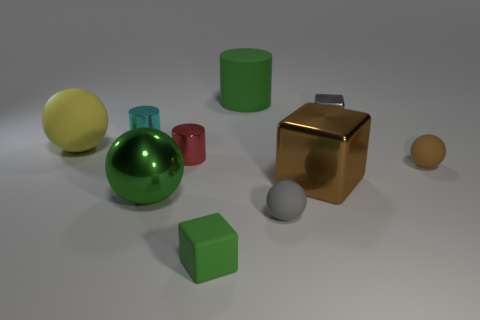Subtract all tiny cubes. How many cubes are left? 1 Subtract 3 spheres. How many spheres are left? 1 Subtract all green cylinders. How many cylinders are left? 2 Subtract all blue cylinders. Subtract all cyan balls. How many cylinders are left? 3 Subtract all purple cubes. How many green cylinders are left? 1 Subtract all tiny blue metallic cylinders. Subtract all small brown balls. How many objects are left? 9 Add 5 tiny gray spheres. How many tiny gray spheres are left? 6 Add 3 small green rubber cubes. How many small green rubber cubes exist? 4 Subtract 1 brown blocks. How many objects are left? 9 Subtract all spheres. How many objects are left? 6 